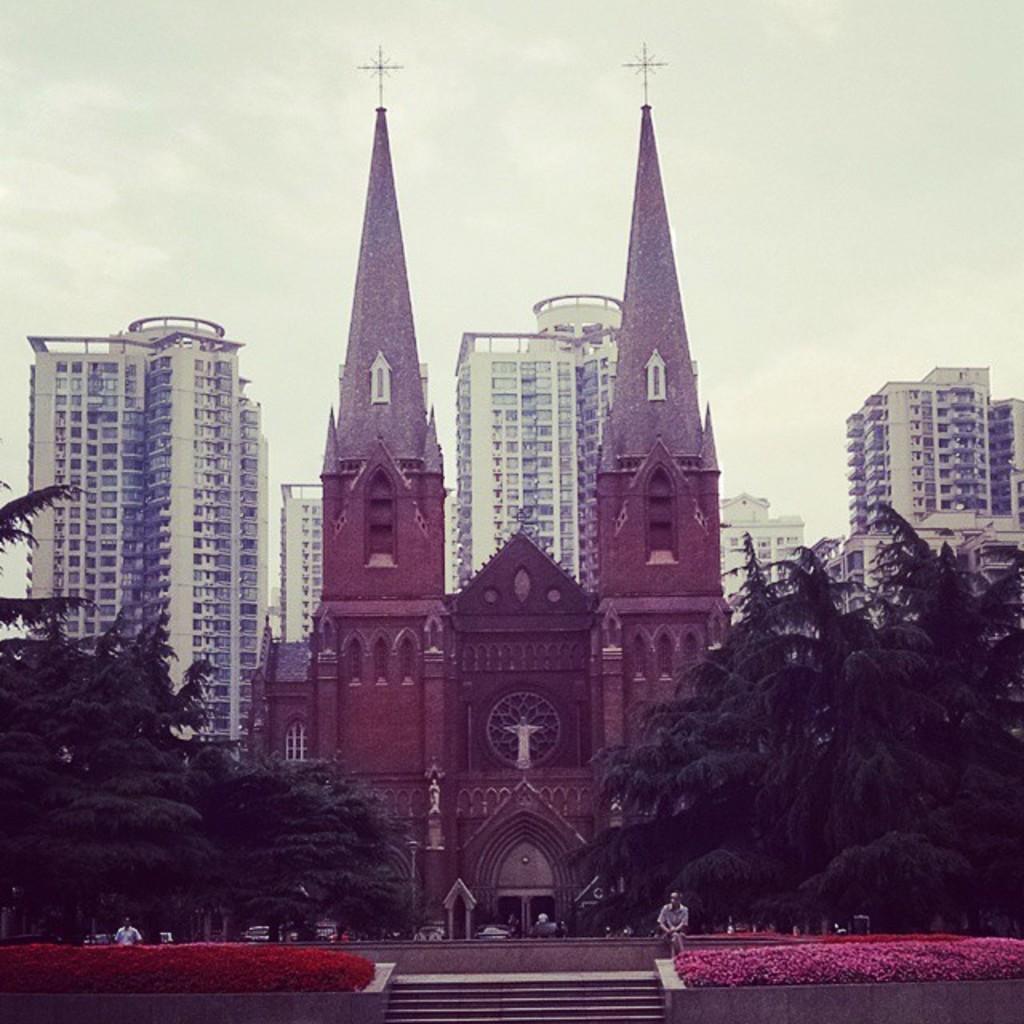Can you describe this image briefly? In this picture we can see few flowers, people, trees and buildings, and we can see a person is seated in front of the building. 